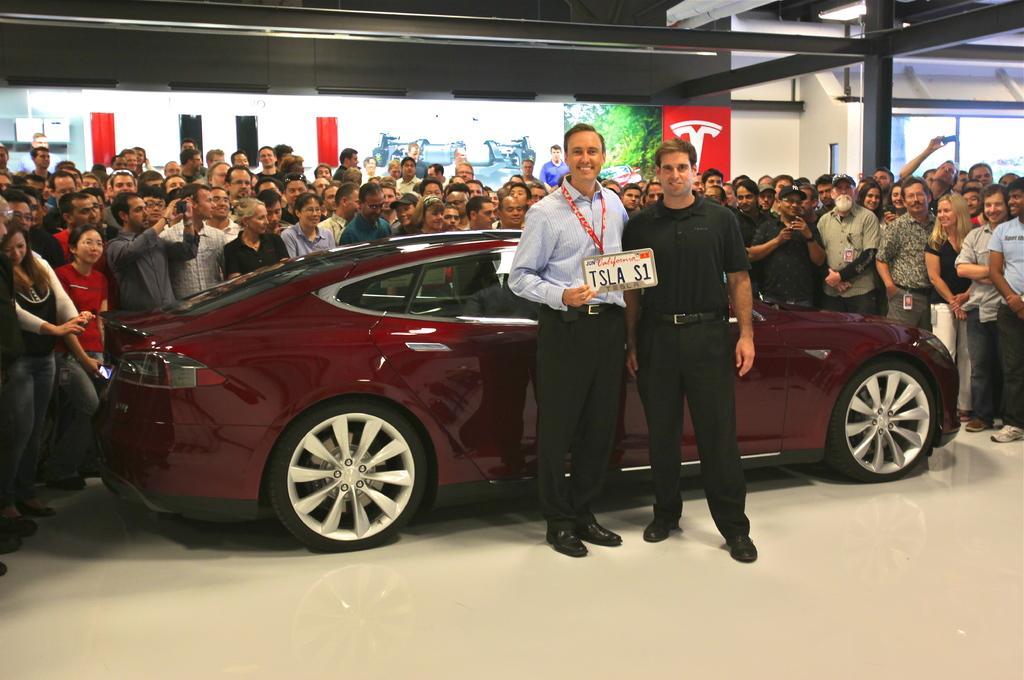Can you describe this image briefly? In this image I can see 2 people standing, the person standing on the left is holding a board and there is a car and people are standing behind them. 